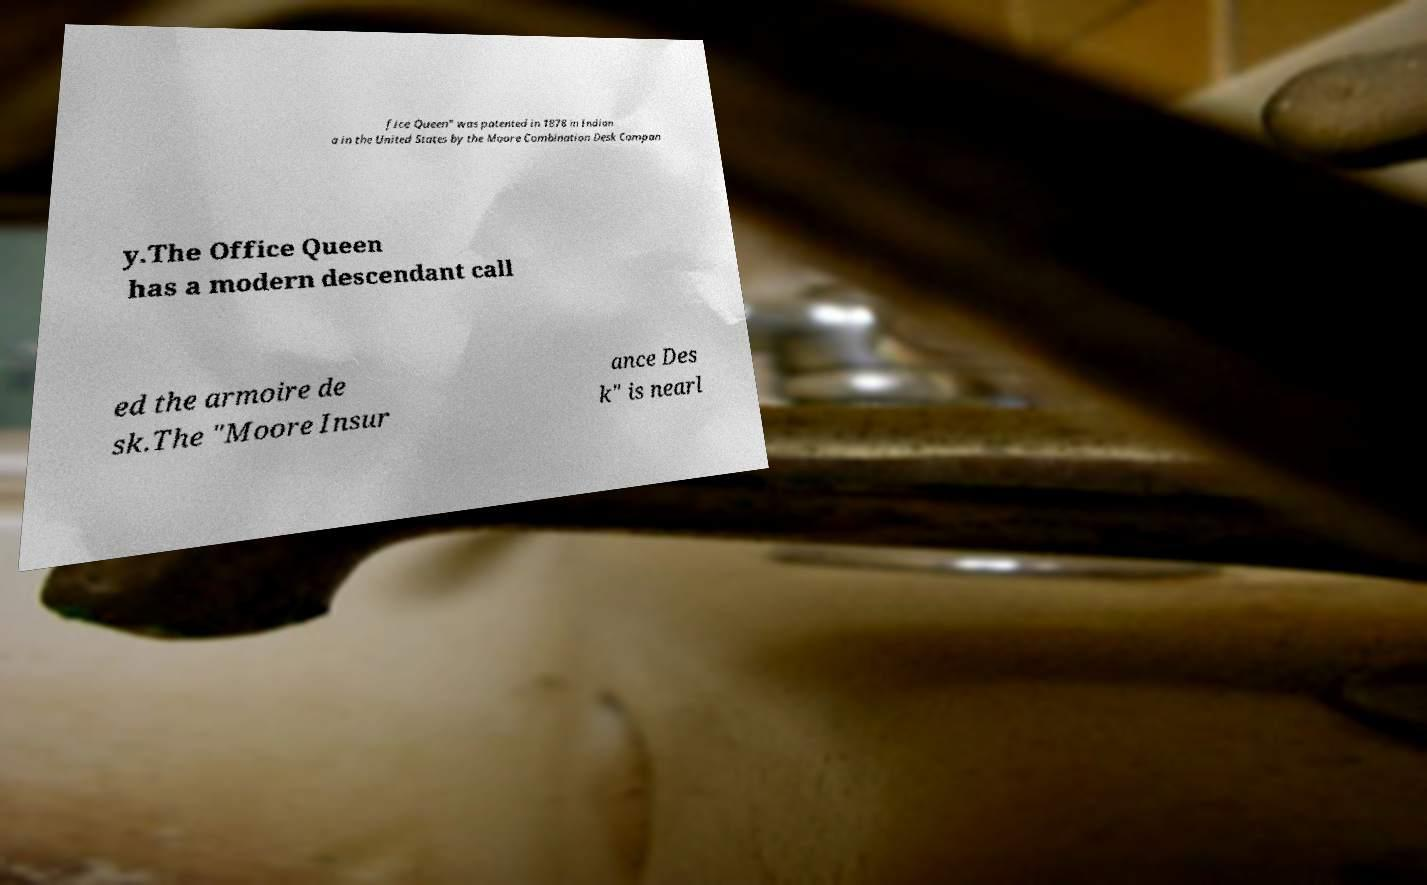What messages or text are displayed in this image? I need them in a readable, typed format. fice Queen" was patented in 1878 in Indian a in the United States by the Moore Combination Desk Compan y.The Office Queen has a modern descendant call ed the armoire de sk.The "Moore Insur ance Des k" is nearl 